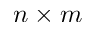Convert formula to latex. <formula><loc_0><loc_0><loc_500><loc_500>n \times m</formula> 